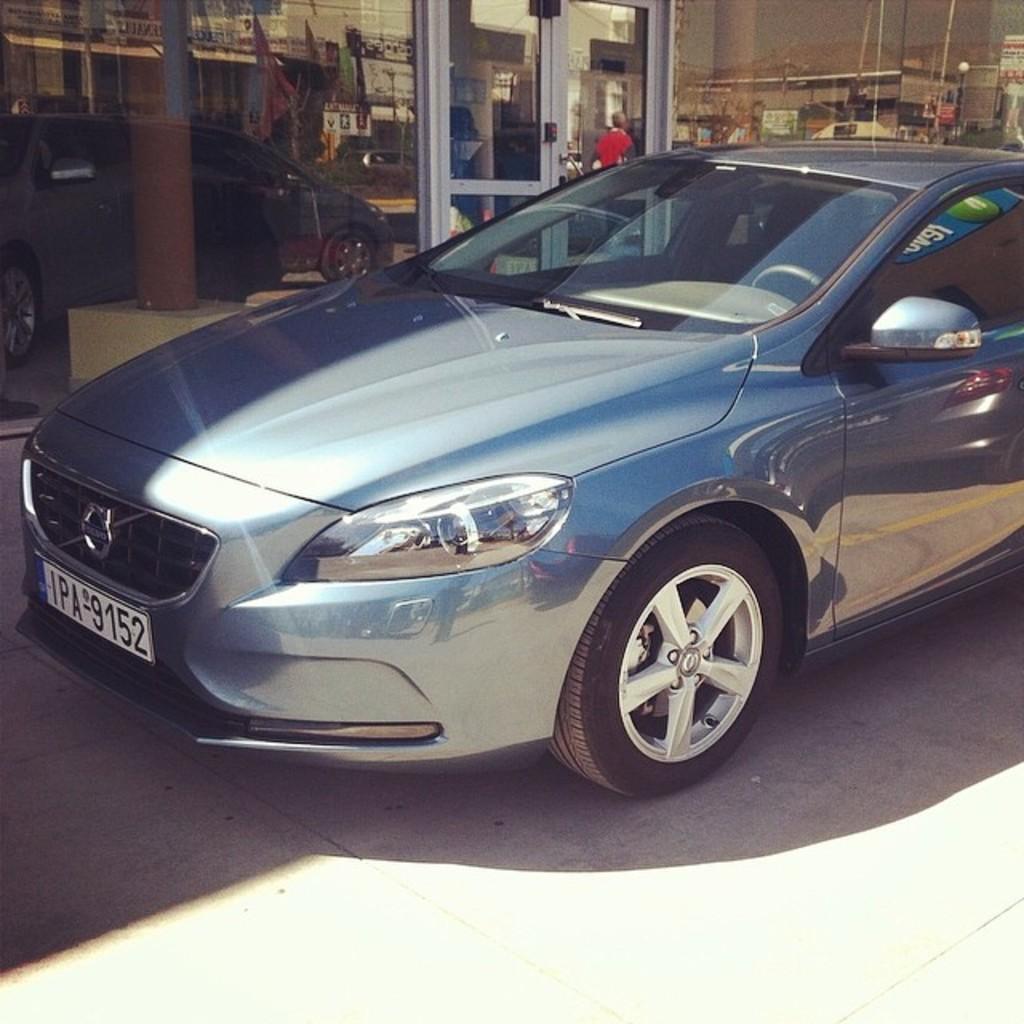Can you describe this image briefly? In the image there is a car on the road and behind there is a building with glass wall and doors, 